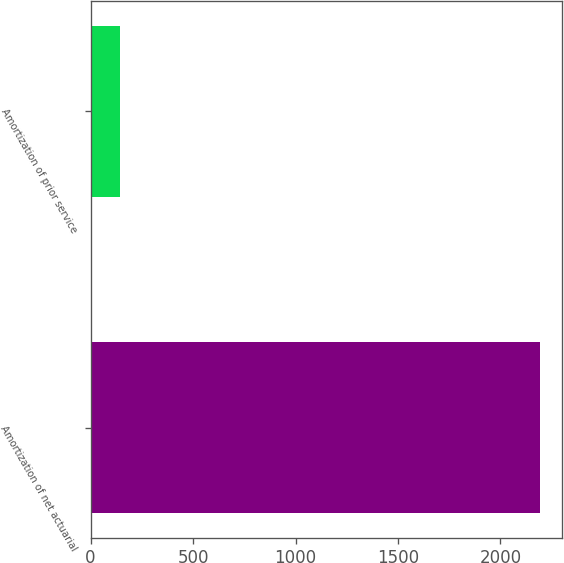Convert chart to OTSL. <chart><loc_0><loc_0><loc_500><loc_500><bar_chart><fcel>Amortization of net actuarial<fcel>Amortization of prior service<nl><fcel>2192<fcel>145<nl></chart> 